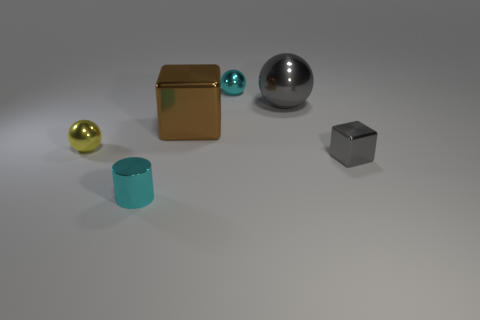How many blocks are either big purple matte objects or large gray things?
Your answer should be compact. 0. What number of cyan objects are on the right side of the tiny gray metallic block that is to the right of the cylinder?
Ensure brevity in your answer.  0. Is the large gray metal thing the same shape as the yellow metal thing?
Your response must be concise. Yes. There is a cyan shiny thing that is the same shape as the yellow metallic object; what size is it?
Give a very brief answer. Small. There is a big thing in front of the big metal ball that is behind the tiny gray cube; what shape is it?
Offer a terse response. Cube. What is the size of the cyan shiny sphere?
Your answer should be compact. Small. The brown shiny object is what shape?
Offer a very short reply. Cube. Is the shape of the yellow object the same as the small metallic object behind the yellow sphere?
Provide a short and direct response. Yes. Do the small cyan metallic object that is behind the brown block and the big gray metallic object have the same shape?
Offer a very short reply. Yes. What number of tiny objects are behind the tiny shiny cube and right of the cyan cylinder?
Give a very brief answer. 1. 